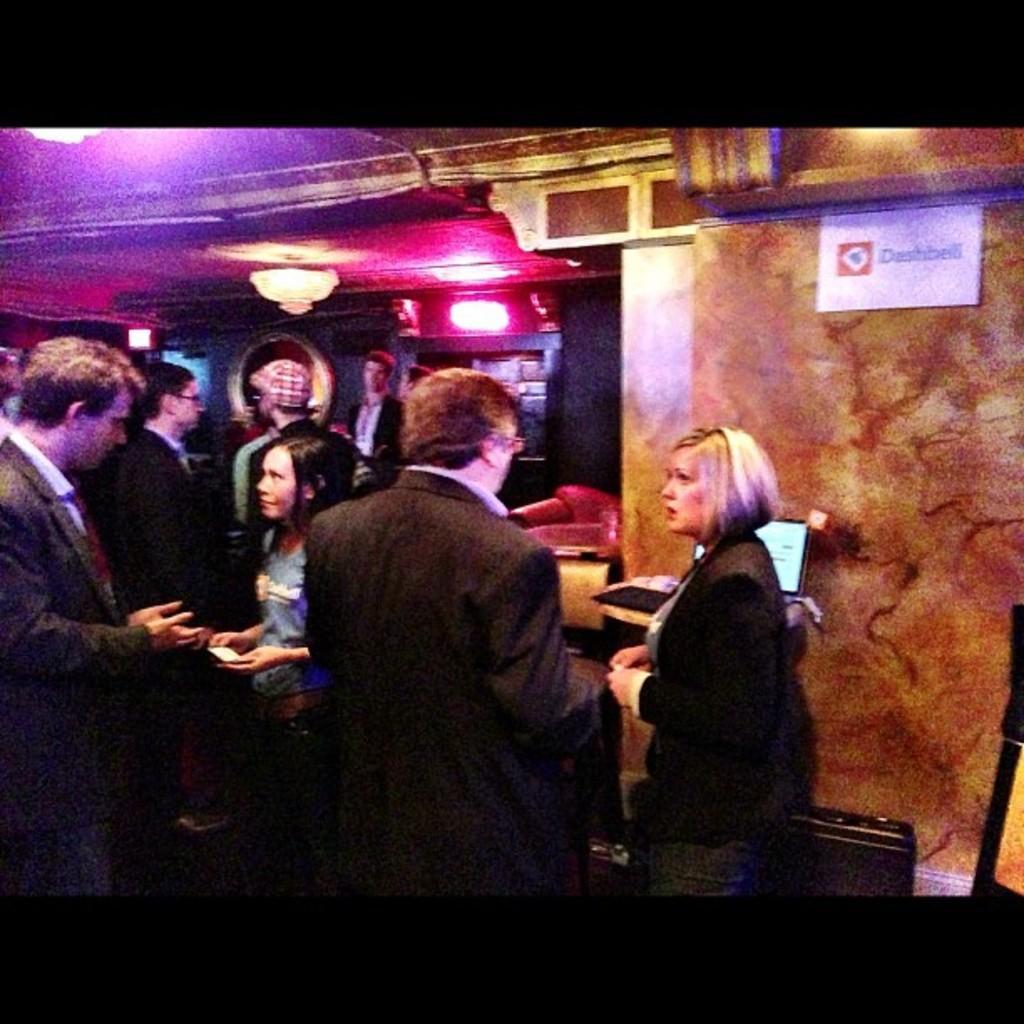Could you give a brief overview of what you see in this image? This is an edited picture. I can see group of people standing, there is a paper on the wall, there is a chandelier and there are some objects. 